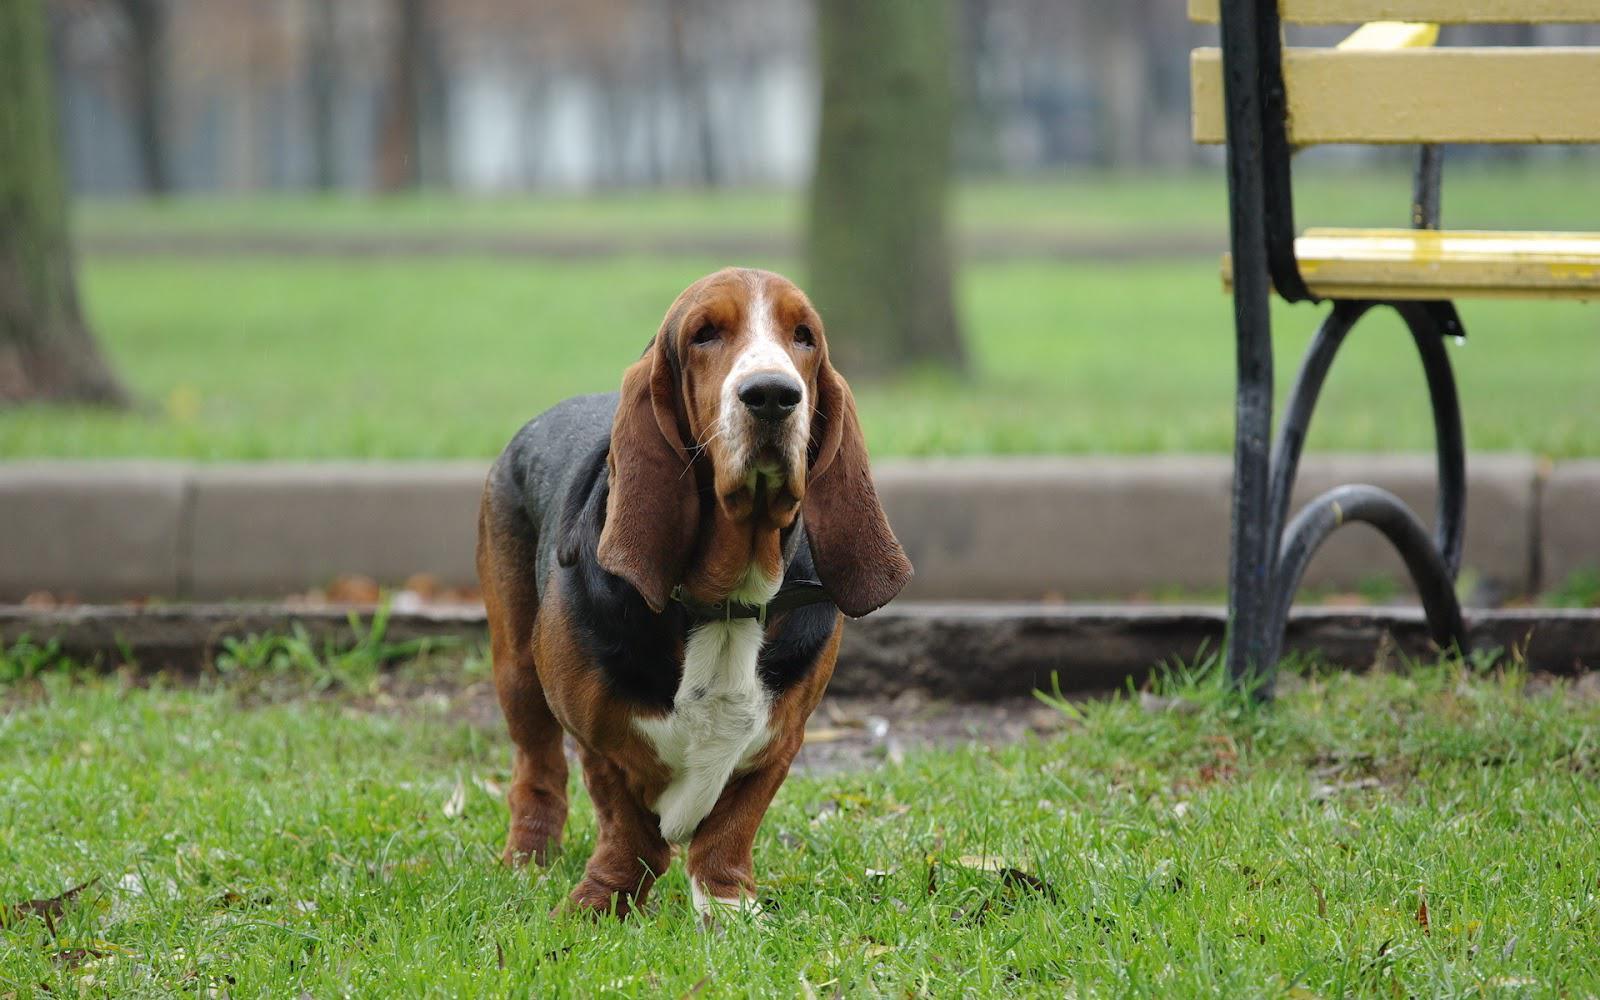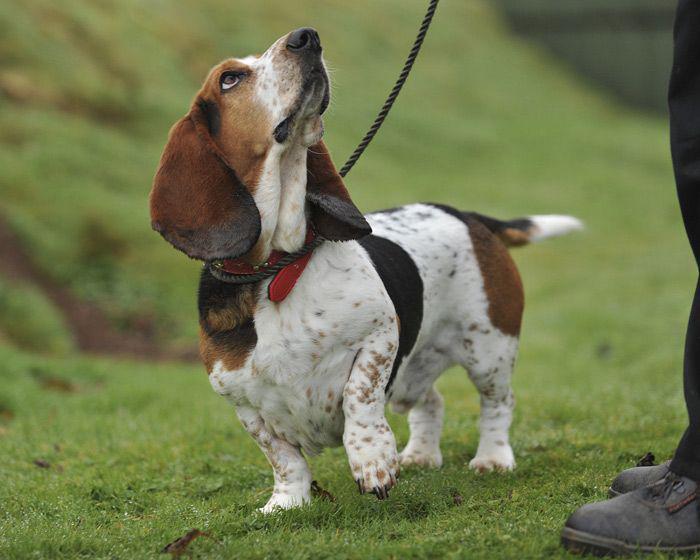The first image is the image on the left, the second image is the image on the right. Considering the images on both sides, is "One of the images shows at least one dog on a leash." valid? Answer yes or no. Yes. The first image is the image on the left, the second image is the image on the right. Evaluate the accuracy of this statement regarding the images: "One image shows just one beagle, with no leash attached.". Is it true? Answer yes or no. Yes. 